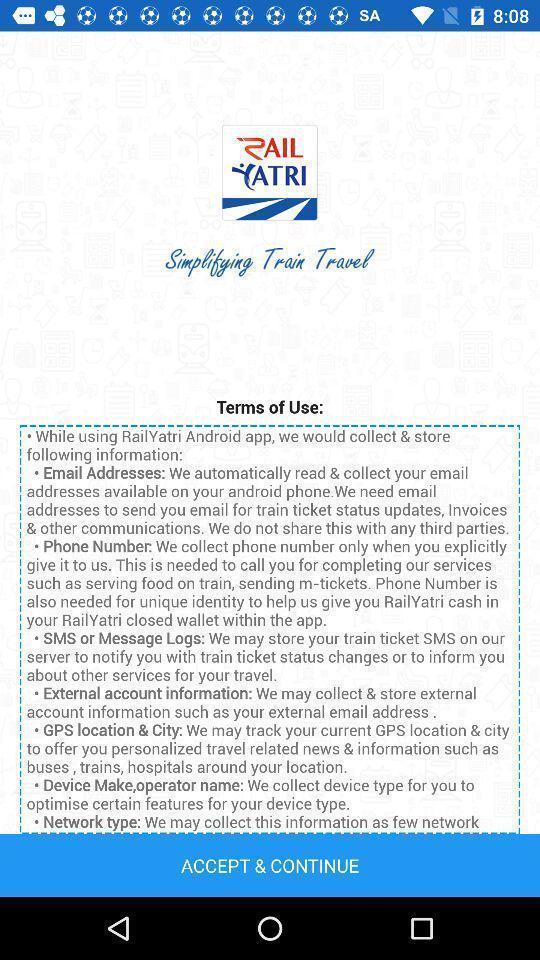Provide a textual representation of this image. Terms of use in travel app. 